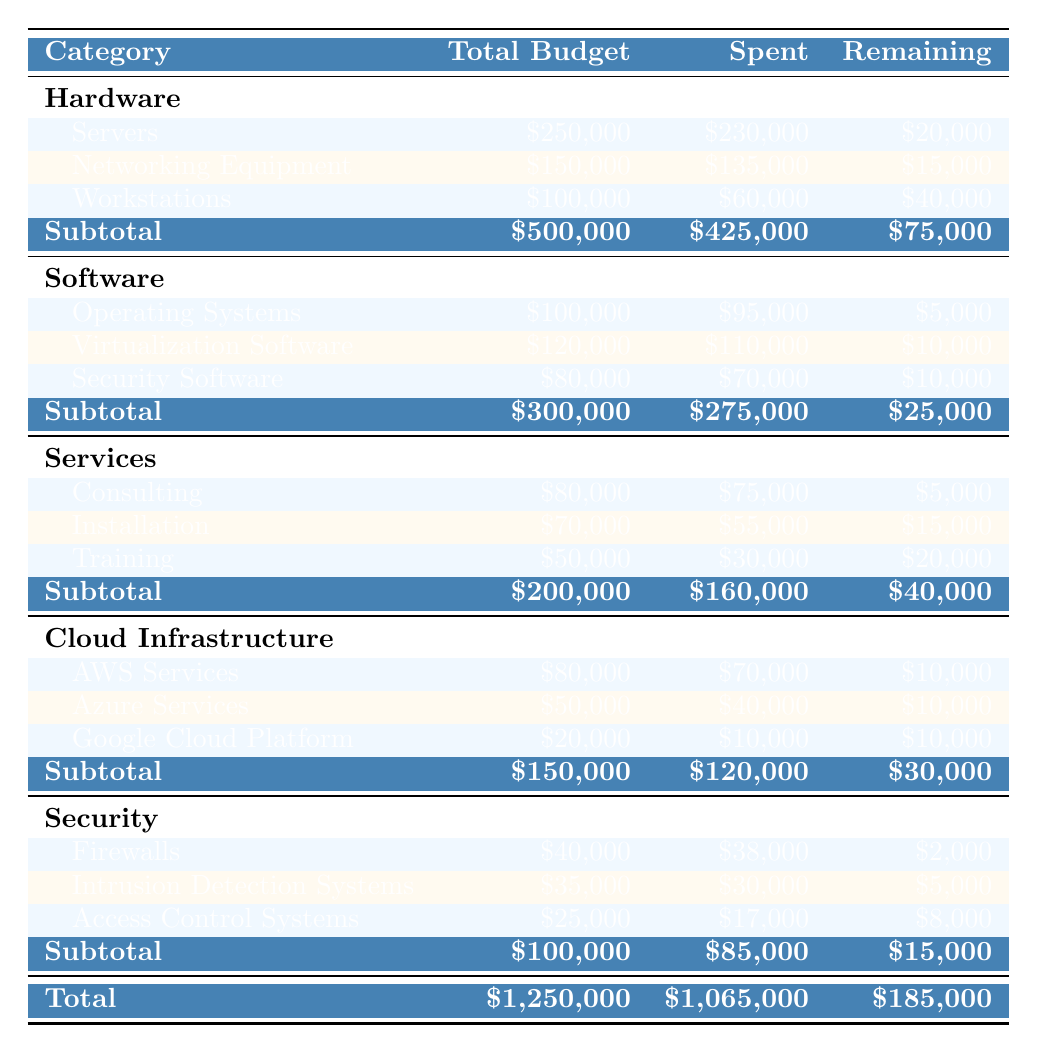What is the total budget for IT infrastructure upgrades? The total budget can be found by summing the total budgets of all categories. These are: Hardware ($500,000), Software ($300,000), Services ($200,000), Cloud Infrastructure ($150,000), and Security ($100,000). Adding these gives $500,000 + $300,000 + $200,000 + $150,000 + $100,000 = $1,250,000.
Answer: $1,250,000 How much has been spent on Software? The amount spent on Software can be found directly in the table under the Software category. It indicates that $275,000 has been spent.
Answer: $275,000 What is the remaining budget for Services? The remaining budget for Services is also provided in the table, under the Services category, showing $40,000 left.
Answer: $40,000 Which subcategory of Hardware has the lowest remaining budget? By comparing the remaining budgets for the subcategories within Hardware, we find: Servers ($20,000), Networking Equipment ($15,000), and Workstations ($40,000). Networking Equipment has the lowest remaining budget at $15,000.
Answer: Networking Equipment What is the total amount spent on Cloud Infrastructure? The total spent on Cloud Infrastructure can be calculated by adding the amounts spent on its subcategories: AWS Services ($70,000), Azure Services ($40,000), and Google Cloud Platform ($10,000). Thus, $70,000 + $40,000 + $10,000 = $120,000.
Answer: $120,000 Is the amount remaining for Firewalls greater than the amount remaining for Access Control Systems? The remaining budget for Firewalls is $2,000, while for Access Control Systems it’s $8,000. Since $2,000 is less than $8,000, the statement is False.
Answer: No What is the average remaining budget across all categories? To find the average, first sum the remaining budgets: Hardware ($75,000), Software ($25,000), Services ($40,000), Cloud Infrastructure ($30,000), and Security ($15,000) gives $75,000 + $25,000 + $40,000 + $30,000 + $15,000 = $215,000. There are 5 categories, so the average is $215,000 / 5 = $43,000.
Answer: $43,000 Which category has the highest percentage of budget spent? To find this, calculate the percentage spent for each category: Hardware: ($425,000 / $500,000) * 100 = 85%, Software: ($275,000 / $300,000) * 100 = 91.67%, Services: ($160,000 / $200,000) * 100 = 80%, Cloud Infrastructure: ($120,000 / $150,000) * 100 = 80%, Security: ($85,000 / $100,000) * 100 = 85%. Software has the highest at 91.67%.
Answer: Software How much more budget remains for Security compared to Services? The remaining budget for Security is $15,000 and for Services it is $40,000. So, to find the difference, we calculate $40,000 - $15,000 = $25,000.
Answer: $25,000 What is the total amount spent across all subcategories of Security? The total spent on Security can be calculated by summing the amounts for Firewalls ($38,000), Intrusion Detection Systems ($30,000), and Access Control Systems ($17,000). This gives $38,000 + $30,000 + $17,000 = $85,000.
Answer: $85,000 